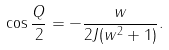<formula> <loc_0><loc_0><loc_500><loc_500>\cos \frac { Q } { 2 } = - \frac { w } { 2 J ( w ^ { 2 } + 1 ) } .</formula> 